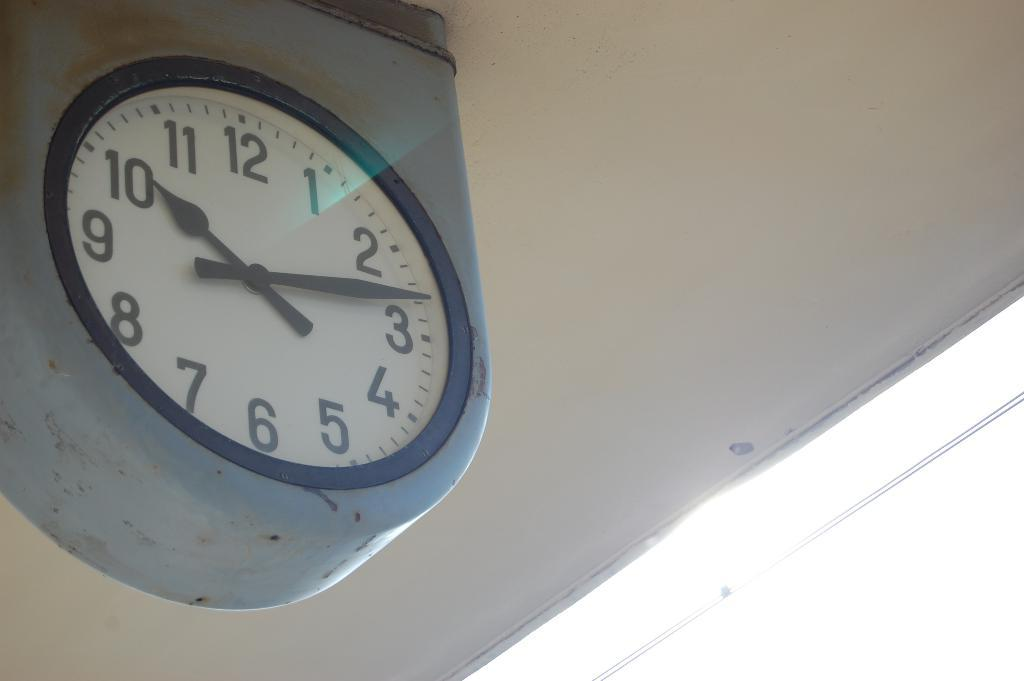<image>
Render a clear and concise summary of the photo. A grey clock has the time of 10:13. 